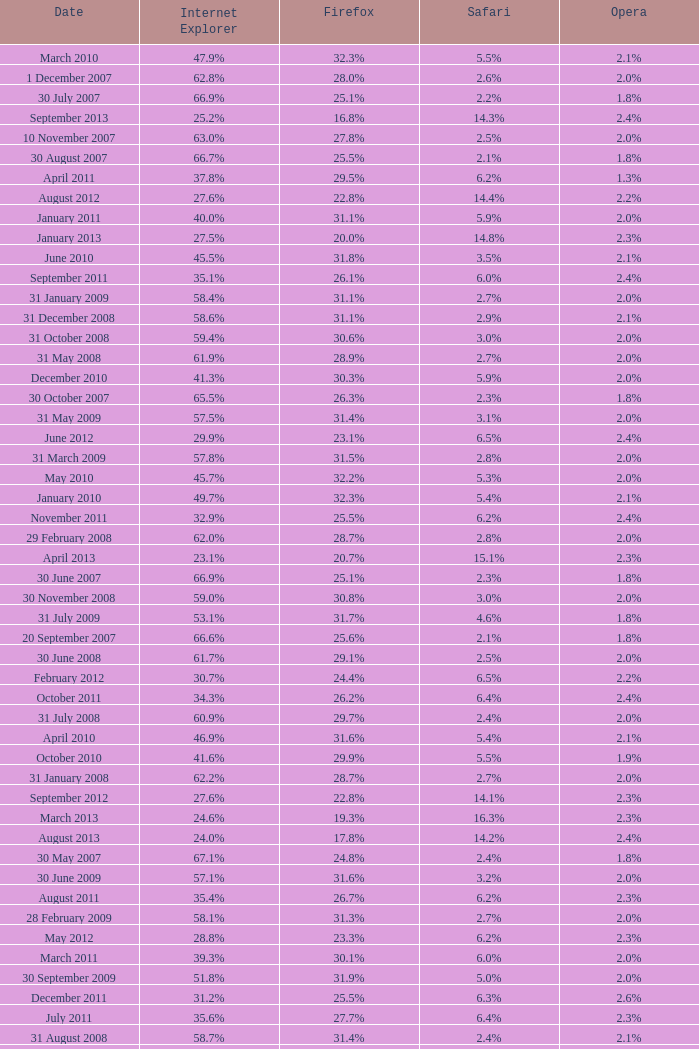What is the firefox value with a 22.0% internet explorer? 19.2%. 